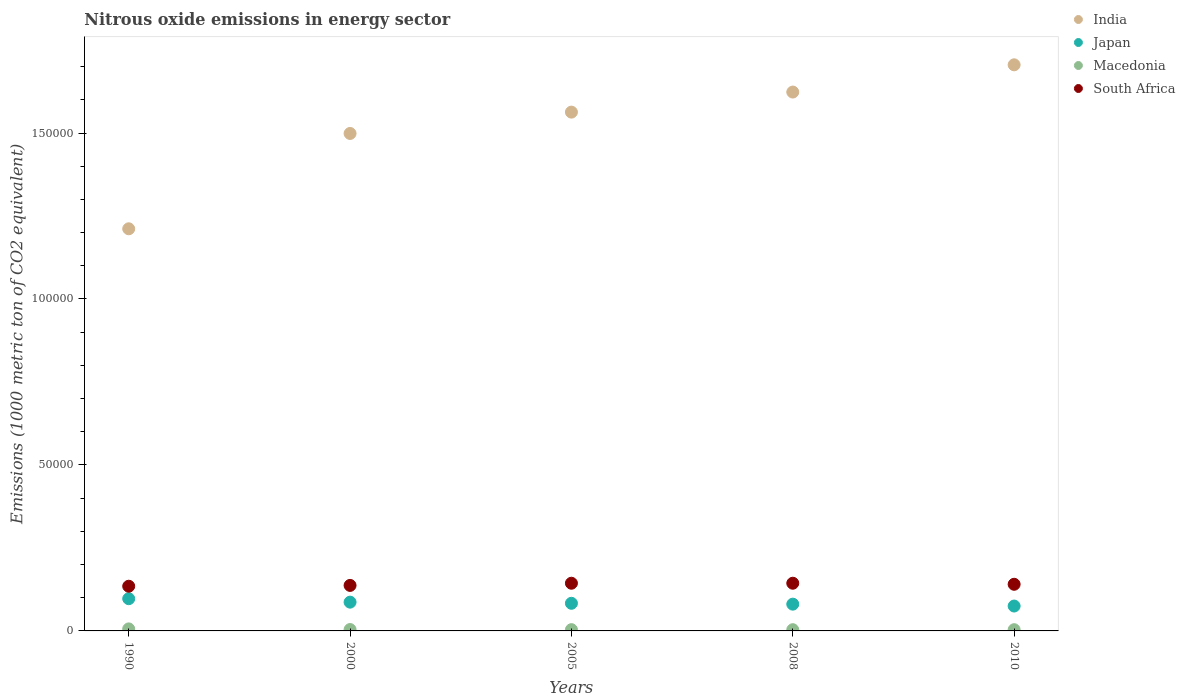What is the amount of nitrous oxide emitted in Macedonia in 2008?
Your response must be concise. 368. Across all years, what is the maximum amount of nitrous oxide emitted in India?
Offer a very short reply. 1.71e+05. Across all years, what is the minimum amount of nitrous oxide emitted in Macedonia?
Provide a succinct answer. 368. In which year was the amount of nitrous oxide emitted in Macedonia maximum?
Your response must be concise. 1990. What is the total amount of nitrous oxide emitted in Macedonia in the graph?
Ensure brevity in your answer.  2151.1. What is the difference between the amount of nitrous oxide emitted in India in 1990 and that in 2000?
Your response must be concise. -2.87e+04. What is the difference between the amount of nitrous oxide emitted in South Africa in 1990 and the amount of nitrous oxide emitted in India in 2010?
Make the answer very short. -1.57e+05. What is the average amount of nitrous oxide emitted in South Africa per year?
Ensure brevity in your answer.  1.40e+04. In the year 2000, what is the difference between the amount of nitrous oxide emitted in India and amount of nitrous oxide emitted in Macedonia?
Your answer should be very brief. 1.49e+05. In how many years, is the amount of nitrous oxide emitted in Macedonia greater than 40000 1000 metric ton?
Give a very brief answer. 0. What is the ratio of the amount of nitrous oxide emitted in India in 2000 to that in 2008?
Provide a succinct answer. 0.92. What is the difference between the highest and the second highest amount of nitrous oxide emitted in Macedonia?
Provide a succinct answer. 192.1. What is the difference between the highest and the lowest amount of nitrous oxide emitted in South Africa?
Provide a succinct answer. 905.7. Is it the case that in every year, the sum of the amount of nitrous oxide emitted in Macedonia and amount of nitrous oxide emitted in India  is greater than the sum of amount of nitrous oxide emitted in South Africa and amount of nitrous oxide emitted in Japan?
Provide a short and direct response. Yes. Does the amount of nitrous oxide emitted in Japan monotonically increase over the years?
Keep it short and to the point. No. Is the amount of nitrous oxide emitted in Japan strictly less than the amount of nitrous oxide emitted in Macedonia over the years?
Offer a terse response. No. How many years are there in the graph?
Give a very brief answer. 5. What is the difference between two consecutive major ticks on the Y-axis?
Your answer should be very brief. 5.00e+04. Does the graph contain grids?
Give a very brief answer. No. Where does the legend appear in the graph?
Give a very brief answer. Top right. How many legend labels are there?
Provide a short and direct response. 4. How are the legend labels stacked?
Offer a very short reply. Vertical. What is the title of the graph?
Ensure brevity in your answer.  Nitrous oxide emissions in energy sector. Does "High income" appear as one of the legend labels in the graph?
Ensure brevity in your answer.  No. What is the label or title of the X-axis?
Provide a short and direct response. Years. What is the label or title of the Y-axis?
Your answer should be compact. Emissions (1000 metric ton of CO2 equivalent). What is the Emissions (1000 metric ton of CO2 equivalent) of India in 1990?
Your response must be concise. 1.21e+05. What is the Emissions (1000 metric ton of CO2 equivalent) in Japan in 1990?
Provide a succinct answer. 9708.8. What is the Emissions (1000 metric ton of CO2 equivalent) in Macedonia in 1990?
Offer a terse response. 610.4. What is the Emissions (1000 metric ton of CO2 equivalent) in South Africa in 1990?
Provide a succinct answer. 1.35e+04. What is the Emissions (1000 metric ton of CO2 equivalent) in India in 2000?
Your answer should be compact. 1.50e+05. What is the Emissions (1000 metric ton of CO2 equivalent) in Japan in 2000?
Your answer should be compact. 8667.2. What is the Emissions (1000 metric ton of CO2 equivalent) in Macedonia in 2000?
Give a very brief answer. 418.3. What is the Emissions (1000 metric ton of CO2 equivalent) of South Africa in 2000?
Your answer should be compact. 1.37e+04. What is the Emissions (1000 metric ton of CO2 equivalent) of India in 2005?
Your answer should be very brief. 1.56e+05. What is the Emissions (1000 metric ton of CO2 equivalent) of Japan in 2005?
Ensure brevity in your answer.  8324.7. What is the Emissions (1000 metric ton of CO2 equivalent) in Macedonia in 2005?
Ensure brevity in your answer.  382.8. What is the Emissions (1000 metric ton of CO2 equivalent) in South Africa in 2005?
Your answer should be compact. 1.44e+04. What is the Emissions (1000 metric ton of CO2 equivalent) of India in 2008?
Provide a succinct answer. 1.62e+05. What is the Emissions (1000 metric ton of CO2 equivalent) of Japan in 2008?
Offer a very short reply. 8063.7. What is the Emissions (1000 metric ton of CO2 equivalent) in Macedonia in 2008?
Offer a terse response. 368. What is the Emissions (1000 metric ton of CO2 equivalent) of South Africa in 2008?
Your response must be concise. 1.44e+04. What is the Emissions (1000 metric ton of CO2 equivalent) of India in 2010?
Give a very brief answer. 1.71e+05. What is the Emissions (1000 metric ton of CO2 equivalent) in Japan in 2010?
Offer a very short reply. 7497.9. What is the Emissions (1000 metric ton of CO2 equivalent) in Macedonia in 2010?
Ensure brevity in your answer.  371.6. What is the Emissions (1000 metric ton of CO2 equivalent) of South Africa in 2010?
Provide a succinct answer. 1.41e+04. Across all years, what is the maximum Emissions (1000 metric ton of CO2 equivalent) in India?
Ensure brevity in your answer.  1.71e+05. Across all years, what is the maximum Emissions (1000 metric ton of CO2 equivalent) of Japan?
Your answer should be very brief. 9708.8. Across all years, what is the maximum Emissions (1000 metric ton of CO2 equivalent) of Macedonia?
Ensure brevity in your answer.  610.4. Across all years, what is the maximum Emissions (1000 metric ton of CO2 equivalent) of South Africa?
Give a very brief answer. 1.44e+04. Across all years, what is the minimum Emissions (1000 metric ton of CO2 equivalent) of India?
Your response must be concise. 1.21e+05. Across all years, what is the minimum Emissions (1000 metric ton of CO2 equivalent) in Japan?
Make the answer very short. 7497.9. Across all years, what is the minimum Emissions (1000 metric ton of CO2 equivalent) of Macedonia?
Keep it short and to the point. 368. Across all years, what is the minimum Emissions (1000 metric ton of CO2 equivalent) of South Africa?
Ensure brevity in your answer.  1.35e+04. What is the total Emissions (1000 metric ton of CO2 equivalent) of India in the graph?
Your answer should be very brief. 7.60e+05. What is the total Emissions (1000 metric ton of CO2 equivalent) of Japan in the graph?
Offer a terse response. 4.23e+04. What is the total Emissions (1000 metric ton of CO2 equivalent) of Macedonia in the graph?
Give a very brief answer. 2151.1. What is the total Emissions (1000 metric ton of CO2 equivalent) of South Africa in the graph?
Make the answer very short. 7.00e+04. What is the difference between the Emissions (1000 metric ton of CO2 equivalent) in India in 1990 and that in 2000?
Your answer should be very brief. -2.87e+04. What is the difference between the Emissions (1000 metric ton of CO2 equivalent) of Japan in 1990 and that in 2000?
Offer a terse response. 1041.6. What is the difference between the Emissions (1000 metric ton of CO2 equivalent) in Macedonia in 1990 and that in 2000?
Your response must be concise. 192.1. What is the difference between the Emissions (1000 metric ton of CO2 equivalent) in South Africa in 1990 and that in 2000?
Keep it short and to the point. -246.5. What is the difference between the Emissions (1000 metric ton of CO2 equivalent) of India in 1990 and that in 2005?
Offer a very short reply. -3.51e+04. What is the difference between the Emissions (1000 metric ton of CO2 equivalent) in Japan in 1990 and that in 2005?
Give a very brief answer. 1384.1. What is the difference between the Emissions (1000 metric ton of CO2 equivalent) of Macedonia in 1990 and that in 2005?
Ensure brevity in your answer.  227.6. What is the difference between the Emissions (1000 metric ton of CO2 equivalent) in South Africa in 1990 and that in 2005?
Make the answer very short. -903.7. What is the difference between the Emissions (1000 metric ton of CO2 equivalent) of India in 1990 and that in 2008?
Give a very brief answer. -4.12e+04. What is the difference between the Emissions (1000 metric ton of CO2 equivalent) in Japan in 1990 and that in 2008?
Keep it short and to the point. 1645.1. What is the difference between the Emissions (1000 metric ton of CO2 equivalent) in Macedonia in 1990 and that in 2008?
Your response must be concise. 242.4. What is the difference between the Emissions (1000 metric ton of CO2 equivalent) of South Africa in 1990 and that in 2008?
Your response must be concise. -905.7. What is the difference between the Emissions (1000 metric ton of CO2 equivalent) in India in 1990 and that in 2010?
Make the answer very short. -4.94e+04. What is the difference between the Emissions (1000 metric ton of CO2 equivalent) in Japan in 1990 and that in 2010?
Give a very brief answer. 2210.9. What is the difference between the Emissions (1000 metric ton of CO2 equivalent) in Macedonia in 1990 and that in 2010?
Your answer should be very brief. 238.8. What is the difference between the Emissions (1000 metric ton of CO2 equivalent) of South Africa in 1990 and that in 2010?
Ensure brevity in your answer.  -588.2. What is the difference between the Emissions (1000 metric ton of CO2 equivalent) in India in 2000 and that in 2005?
Offer a very short reply. -6428.4. What is the difference between the Emissions (1000 metric ton of CO2 equivalent) in Japan in 2000 and that in 2005?
Offer a terse response. 342.5. What is the difference between the Emissions (1000 metric ton of CO2 equivalent) in Macedonia in 2000 and that in 2005?
Your answer should be compact. 35.5. What is the difference between the Emissions (1000 metric ton of CO2 equivalent) of South Africa in 2000 and that in 2005?
Make the answer very short. -657.2. What is the difference between the Emissions (1000 metric ton of CO2 equivalent) of India in 2000 and that in 2008?
Your answer should be very brief. -1.25e+04. What is the difference between the Emissions (1000 metric ton of CO2 equivalent) in Japan in 2000 and that in 2008?
Keep it short and to the point. 603.5. What is the difference between the Emissions (1000 metric ton of CO2 equivalent) in Macedonia in 2000 and that in 2008?
Offer a terse response. 50.3. What is the difference between the Emissions (1000 metric ton of CO2 equivalent) in South Africa in 2000 and that in 2008?
Your answer should be very brief. -659.2. What is the difference between the Emissions (1000 metric ton of CO2 equivalent) of India in 2000 and that in 2010?
Your response must be concise. -2.07e+04. What is the difference between the Emissions (1000 metric ton of CO2 equivalent) of Japan in 2000 and that in 2010?
Keep it short and to the point. 1169.3. What is the difference between the Emissions (1000 metric ton of CO2 equivalent) of Macedonia in 2000 and that in 2010?
Ensure brevity in your answer.  46.7. What is the difference between the Emissions (1000 metric ton of CO2 equivalent) of South Africa in 2000 and that in 2010?
Your answer should be very brief. -341.7. What is the difference between the Emissions (1000 metric ton of CO2 equivalent) of India in 2005 and that in 2008?
Keep it short and to the point. -6044.2. What is the difference between the Emissions (1000 metric ton of CO2 equivalent) in Japan in 2005 and that in 2008?
Keep it short and to the point. 261. What is the difference between the Emissions (1000 metric ton of CO2 equivalent) of South Africa in 2005 and that in 2008?
Provide a succinct answer. -2. What is the difference between the Emissions (1000 metric ton of CO2 equivalent) in India in 2005 and that in 2010?
Your answer should be very brief. -1.43e+04. What is the difference between the Emissions (1000 metric ton of CO2 equivalent) of Japan in 2005 and that in 2010?
Offer a very short reply. 826.8. What is the difference between the Emissions (1000 metric ton of CO2 equivalent) in Macedonia in 2005 and that in 2010?
Ensure brevity in your answer.  11.2. What is the difference between the Emissions (1000 metric ton of CO2 equivalent) of South Africa in 2005 and that in 2010?
Offer a very short reply. 315.5. What is the difference between the Emissions (1000 metric ton of CO2 equivalent) of India in 2008 and that in 2010?
Give a very brief answer. -8207.6. What is the difference between the Emissions (1000 metric ton of CO2 equivalent) of Japan in 2008 and that in 2010?
Your response must be concise. 565.8. What is the difference between the Emissions (1000 metric ton of CO2 equivalent) in South Africa in 2008 and that in 2010?
Offer a very short reply. 317.5. What is the difference between the Emissions (1000 metric ton of CO2 equivalent) of India in 1990 and the Emissions (1000 metric ton of CO2 equivalent) of Japan in 2000?
Provide a short and direct response. 1.12e+05. What is the difference between the Emissions (1000 metric ton of CO2 equivalent) in India in 1990 and the Emissions (1000 metric ton of CO2 equivalent) in Macedonia in 2000?
Your response must be concise. 1.21e+05. What is the difference between the Emissions (1000 metric ton of CO2 equivalent) of India in 1990 and the Emissions (1000 metric ton of CO2 equivalent) of South Africa in 2000?
Your response must be concise. 1.07e+05. What is the difference between the Emissions (1000 metric ton of CO2 equivalent) in Japan in 1990 and the Emissions (1000 metric ton of CO2 equivalent) in Macedonia in 2000?
Provide a succinct answer. 9290.5. What is the difference between the Emissions (1000 metric ton of CO2 equivalent) in Japan in 1990 and the Emissions (1000 metric ton of CO2 equivalent) in South Africa in 2000?
Your answer should be compact. -4001.1. What is the difference between the Emissions (1000 metric ton of CO2 equivalent) of Macedonia in 1990 and the Emissions (1000 metric ton of CO2 equivalent) of South Africa in 2000?
Offer a terse response. -1.31e+04. What is the difference between the Emissions (1000 metric ton of CO2 equivalent) of India in 1990 and the Emissions (1000 metric ton of CO2 equivalent) of Japan in 2005?
Your answer should be very brief. 1.13e+05. What is the difference between the Emissions (1000 metric ton of CO2 equivalent) of India in 1990 and the Emissions (1000 metric ton of CO2 equivalent) of Macedonia in 2005?
Keep it short and to the point. 1.21e+05. What is the difference between the Emissions (1000 metric ton of CO2 equivalent) of India in 1990 and the Emissions (1000 metric ton of CO2 equivalent) of South Africa in 2005?
Make the answer very short. 1.07e+05. What is the difference between the Emissions (1000 metric ton of CO2 equivalent) in Japan in 1990 and the Emissions (1000 metric ton of CO2 equivalent) in Macedonia in 2005?
Ensure brevity in your answer.  9326. What is the difference between the Emissions (1000 metric ton of CO2 equivalent) in Japan in 1990 and the Emissions (1000 metric ton of CO2 equivalent) in South Africa in 2005?
Make the answer very short. -4658.3. What is the difference between the Emissions (1000 metric ton of CO2 equivalent) in Macedonia in 1990 and the Emissions (1000 metric ton of CO2 equivalent) in South Africa in 2005?
Offer a terse response. -1.38e+04. What is the difference between the Emissions (1000 metric ton of CO2 equivalent) in India in 1990 and the Emissions (1000 metric ton of CO2 equivalent) in Japan in 2008?
Provide a succinct answer. 1.13e+05. What is the difference between the Emissions (1000 metric ton of CO2 equivalent) of India in 1990 and the Emissions (1000 metric ton of CO2 equivalent) of Macedonia in 2008?
Your answer should be compact. 1.21e+05. What is the difference between the Emissions (1000 metric ton of CO2 equivalent) of India in 1990 and the Emissions (1000 metric ton of CO2 equivalent) of South Africa in 2008?
Offer a very short reply. 1.07e+05. What is the difference between the Emissions (1000 metric ton of CO2 equivalent) in Japan in 1990 and the Emissions (1000 metric ton of CO2 equivalent) in Macedonia in 2008?
Make the answer very short. 9340.8. What is the difference between the Emissions (1000 metric ton of CO2 equivalent) of Japan in 1990 and the Emissions (1000 metric ton of CO2 equivalent) of South Africa in 2008?
Provide a succinct answer. -4660.3. What is the difference between the Emissions (1000 metric ton of CO2 equivalent) of Macedonia in 1990 and the Emissions (1000 metric ton of CO2 equivalent) of South Africa in 2008?
Keep it short and to the point. -1.38e+04. What is the difference between the Emissions (1000 metric ton of CO2 equivalent) in India in 1990 and the Emissions (1000 metric ton of CO2 equivalent) in Japan in 2010?
Provide a short and direct response. 1.14e+05. What is the difference between the Emissions (1000 metric ton of CO2 equivalent) in India in 1990 and the Emissions (1000 metric ton of CO2 equivalent) in Macedonia in 2010?
Provide a succinct answer. 1.21e+05. What is the difference between the Emissions (1000 metric ton of CO2 equivalent) of India in 1990 and the Emissions (1000 metric ton of CO2 equivalent) of South Africa in 2010?
Your response must be concise. 1.07e+05. What is the difference between the Emissions (1000 metric ton of CO2 equivalent) in Japan in 1990 and the Emissions (1000 metric ton of CO2 equivalent) in Macedonia in 2010?
Give a very brief answer. 9337.2. What is the difference between the Emissions (1000 metric ton of CO2 equivalent) in Japan in 1990 and the Emissions (1000 metric ton of CO2 equivalent) in South Africa in 2010?
Your response must be concise. -4342.8. What is the difference between the Emissions (1000 metric ton of CO2 equivalent) in Macedonia in 1990 and the Emissions (1000 metric ton of CO2 equivalent) in South Africa in 2010?
Your answer should be compact. -1.34e+04. What is the difference between the Emissions (1000 metric ton of CO2 equivalent) of India in 2000 and the Emissions (1000 metric ton of CO2 equivalent) of Japan in 2005?
Ensure brevity in your answer.  1.42e+05. What is the difference between the Emissions (1000 metric ton of CO2 equivalent) of India in 2000 and the Emissions (1000 metric ton of CO2 equivalent) of Macedonia in 2005?
Provide a succinct answer. 1.49e+05. What is the difference between the Emissions (1000 metric ton of CO2 equivalent) of India in 2000 and the Emissions (1000 metric ton of CO2 equivalent) of South Africa in 2005?
Give a very brief answer. 1.36e+05. What is the difference between the Emissions (1000 metric ton of CO2 equivalent) in Japan in 2000 and the Emissions (1000 metric ton of CO2 equivalent) in Macedonia in 2005?
Offer a terse response. 8284.4. What is the difference between the Emissions (1000 metric ton of CO2 equivalent) of Japan in 2000 and the Emissions (1000 metric ton of CO2 equivalent) of South Africa in 2005?
Make the answer very short. -5699.9. What is the difference between the Emissions (1000 metric ton of CO2 equivalent) of Macedonia in 2000 and the Emissions (1000 metric ton of CO2 equivalent) of South Africa in 2005?
Your response must be concise. -1.39e+04. What is the difference between the Emissions (1000 metric ton of CO2 equivalent) in India in 2000 and the Emissions (1000 metric ton of CO2 equivalent) in Japan in 2008?
Your response must be concise. 1.42e+05. What is the difference between the Emissions (1000 metric ton of CO2 equivalent) in India in 2000 and the Emissions (1000 metric ton of CO2 equivalent) in Macedonia in 2008?
Ensure brevity in your answer.  1.50e+05. What is the difference between the Emissions (1000 metric ton of CO2 equivalent) of India in 2000 and the Emissions (1000 metric ton of CO2 equivalent) of South Africa in 2008?
Give a very brief answer. 1.36e+05. What is the difference between the Emissions (1000 metric ton of CO2 equivalent) in Japan in 2000 and the Emissions (1000 metric ton of CO2 equivalent) in Macedonia in 2008?
Give a very brief answer. 8299.2. What is the difference between the Emissions (1000 metric ton of CO2 equivalent) in Japan in 2000 and the Emissions (1000 metric ton of CO2 equivalent) in South Africa in 2008?
Ensure brevity in your answer.  -5701.9. What is the difference between the Emissions (1000 metric ton of CO2 equivalent) in Macedonia in 2000 and the Emissions (1000 metric ton of CO2 equivalent) in South Africa in 2008?
Offer a very short reply. -1.40e+04. What is the difference between the Emissions (1000 metric ton of CO2 equivalent) in India in 2000 and the Emissions (1000 metric ton of CO2 equivalent) in Japan in 2010?
Your response must be concise. 1.42e+05. What is the difference between the Emissions (1000 metric ton of CO2 equivalent) of India in 2000 and the Emissions (1000 metric ton of CO2 equivalent) of Macedonia in 2010?
Your response must be concise. 1.49e+05. What is the difference between the Emissions (1000 metric ton of CO2 equivalent) in India in 2000 and the Emissions (1000 metric ton of CO2 equivalent) in South Africa in 2010?
Offer a very short reply. 1.36e+05. What is the difference between the Emissions (1000 metric ton of CO2 equivalent) of Japan in 2000 and the Emissions (1000 metric ton of CO2 equivalent) of Macedonia in 2010?
Provide a succinct answer. 8295.6. What is the difference between the Emissions (1000 metric ton of CO2 equivalent) in Japan in 2000 and the Emissions (1000 metric ton of CO2 equivalent) in South Africa in 2010?
Provide a succinct answer. -5384.4. What is the difference between the Emissions (1000 metric ton of CO2 equivalent) of Macedonia in 2000 and the Emissions (1000 metric ton of CO2 equivalent) of South Africa in 2010?
Offer a terse response. -1.36e+04. What is the difference between the Emissions (1000 metric ton of CO2 equivalent) of India in 2005 and the Emissions (1000 metric ton of CO2 equivalent) of Japan in 2008?
Give a very brief answer. 1.48e+05. What is the difference between the Emissions (1000 metric ton of CO2 equivalent) in India in 2005 and the Emissions (1000 metric ton of CO2 equivalent) in Macedonia in 2008?
Your response must be concise. 1.56e+05. What is the difference between the Emissions (1000 metric ton of CO2 equivalent) in India in 2005 and the Emissions (1000 metric ton of CO2 equivalent) in South Africa in 2008?
Your answer should be very brief. 1.42e+05. What is the difference between the Emissions (1000 metric ton of CO2 equivalent) of Japan in 2005 and the Emissions (1000 metric ton of CO2 equivalent) of Macedonia in 2008?
Ensure brevity in your answer.  7956.7. What is the difference between the Emissions (1000 metric ton of CO2 equivalent) in Japan in 2005 and the Emissions (1000 metric ton of CO2 equivalent) in South Africa in 2008?
Provide a short and direct response. -6044.4. What is the difference between the Emissions (1000 metric ton of CO2 equivalent) in Macedonia in 2005 and the Emissions (1000 metric ton of CO2 equivalent) in South Africa in 2008?
Provide a succinct answer. -1.40e+04. What is the difference between the Emissions (1000 metric ton of CO2 equivalent) in India in 2005 and the Emissions (1000 metric ton of CO2 equivalent) in Japan in 2010?
Give a very brief answer. 1.49e+05. What is the difference between the Emissions (1000 metric ton of CO2 equivalent) in India in 2005 and the Emissions (1000 metric ton of CO2 equivalent) in Macedonia in 2010?
Offer a very short reply. 1.56e+05. What is the difference between the Emissions (1000 metric ton of CO2 equivalent) in India in 2005 and the Emissions (1000 metric ton of CO2 equivalent) in South Africa in 2010?
Your answer should be compact. 1.42e+05. What is the difference between the Emissions (1000 metric ton of CO2 equivalent) in Japan in 2005 and the Emissions (1000 metric ton of CO2 equivalent) in Macedonia in 2010?
Ensure brevity in your answer.  7953.1. What is the difference between the Emissions (1000 metric ton of CO2 equivalent) in Japan in 2005 and the Emissions (1000 metric ton of CO2 equivalent) in South Africa in 2010?
Your answer should be very brief. -5726.9. What is the difference between the Emissions (1000 metric ton of CO2 equivalent) in Macedonia in 2005 and the Emissions (1000 metric ton of CO2 equivalent) in South Africa in 2010?
Make the answer very short. -1.37e+04. What is the difference between the Emissions (1000 metric ton of CO2 equivalent) of India in 2008 and the Emissions (1000 metric ton of CO2 equivalent) of Japan in 2010?
Your response must be concise. 1.55e+05. What is the difference between the Emissions (1000 metric ton of CO2 equivalent) in India in 2008 and the Emissions (1000 metric ton of CO2 equivalent) in Macedonia in 2010?
Your response must be concise. 1.62e+05. What is the difference between the Emissions (1000 metric ton of CO2 equivalent) of India in 2008 and the Emissions (1000 metric ton of CO2 equivalent) of South Africa in 2010?
Keep it short and to the point. 1.48e+05. What is the difference between the Emissions (1000 metric ton of CO2 equivalent) of Japan in 2008 and the Emissions (1000 metric ton of CO2 equivalent) of Macedonia in 2010?
Your answer should be very brief. 7692.1. What is the difference between the Emissions (1000 metric ton of CO2 equivalent) of Japan in 2008 and the Emissions (1000 metric ton of CO2 equivalent) of South Africa in 2010?
Ensure brevity in your answer.  -5987.9. What is the difference between the Emissions (1000 metric ton of CO2 equivalent) of Macedonia in 2008 and the Emissions (1000 metric ton of CO2 equivalent) of South Africa in 2010?
Keep it short and to the point. -1.37e+04. What is the average Emissions (1000 metric ton of CO2 equivalent) of India per year?
Provide a short and direct response. 1.52e+05. What is the average Emissions (1000 metric ton of CO2 equivalent) in Japan per year?
Provide a succinct answer. 8452.46. What is the average Emissions (1000 metric ton of CO2 equivalent) of Macedonia per year?
Make the answer very short. 430.22. What is the average Emissions (1000 metric ton of CO2 equivalent) in South Africa per year?
Provide a short and direct response. 1.40e+04. In the year 1990, what is the difference between the Emissions (1000 metric ton of CO2 equivalent) of India and Emissions (1000 metric ton of CO2 equivalent) of Japan?
Provide a short and direct response. 1.11e+05. In the year 1990, what is the difference between the Emissions (1000 metric ton of CO2 equivalent) of India and Emissions (1000 metric ton of CO2 equivalent) of Macedonia?
Offer a terse response. 1.21e+05. In the year 1990, what is the difference between the Emissions (1000 metric ton of CO2 equivalent) of India and Emissions (1000 metric ton of CO2 equivalent) of South Africa?
Offer a very short reply. 1.08e+05. In the year 1990, what is the difference between the Emissions (1000 metric ton of CO2 equivalent) of Japan and Emissions (1000 metric ton of CO2 equivalent) of Macedonia?
Provide a short and direct response. 9098.4. In the year 1990, what is the difference between the Emissions (1000 metric ton of CO2 equivalent) in Japan and Emissions (1000 metric ton of CO2 equivalent) in South Africa?
Ensure brevity in your answer.  -3754.6. In the year 1990, what is the difference between the Emissions (1000 metric ton of CO2 equivalent) in Macedonia and Emissions (1000 metric ton of CO2 equivalent) in South Africa?
Make the answer very short. -1.29e+04. In the year 2000, what is the difference between the Emissions (1000 metric ton of CO2 equivalent) in India and Emissions (1000 metric ton of CO2 equivalent) in Japan?
Keep it short and to the point. 1.41e+05. In the year 2000, what is the difference between the Emissions (1000 metric ton of CO2 equivalent) in India and Emissions (1000 metric ton of CO2 equivalent) in Macedonia?
Make the answer very short. 1.49e+05. In the year 2000, what is the difference between the Emissions (1000 metric ton of CO2 equivalent) of India and Emissions (1000 metric ton of CO2 equivalent) of South Africa?
Make the answer very short. 1.36e+05. In the year 2000, what is the difference between the Emissions (1000 metric ton of CO2 equivalent) in Japan and Emissions (1000 metric ton of CO2 equivalent) in Macedonia?
Your answer should be very brief. 8248.9. In the year 2000, what is the difference between the Emissions (1000 metric ton of CO2 equivalent) in Japan and Emissions (1000 metric ton of CO2 equivalent) in South Africa?
Your response must be concise. -5042.7. In the year 2000, what is the difference between the Emissions (1000 metric ton of CO2 equivalent) in Macedonia and Emissions (1000 metric ton of CO2 equivalent) in South Africa?
Your answer should be compact. -1.33e+04. In the year 2005, what is the difference between the Emissions (1000 metric ton of CO2 equivalent) of India and Emissions (1000 metric ton of CO2 equivalent) of Japan?
Offer a terse response. 1.48e+05. In the year 2005, what is the difference between the Emissions (1000 metric ton of CO2 equivalent) in India and Emissions (1000 metric ton of CO2 equivalent) in Macedonia?
Make the answer very short. 1.56e+05. In the year 2005, what is the difference between the Emissions (1000 metric ton of CO2 equivalent) in India and Emissions (1000 metric ton of CO2 equivalent) in South Africa?
Your answer should be very brief. 1.42e+05. In the year 2005, what is the difference between the Emissions (1000 metric ton of CO2 equivalent) of Japan and Emissions (1000 metric ton of CO2 equivalent) of Macedonia?
Your answer should be very brief. 7941.9. In the year 2005, what is the difference between the Emissions (1000 metric ton of CO2 equivalent) in Japan and Emissions (1000 metric ton of CO2 equivalent) in South Africa?
Offer a terse response. -6042.4. In the year 2005, what is the difference between the Emissions (1000 metric ton of CO2 equivalent) of Macedonia and Emissions (1000 metric ton of CO2 equivalent) of South Africa?
Provide a short and direct response. -1.40e+04. In the year 2008, what is the difference between the Emissions (1000 metric ton of CO2 equivalent) of India and Emissions (1000 metric ton of CO2 equivalent) of Japan?
Provide a succinct answer. 1.54e+05. In the year 2008, what is the difference between the Emissions (1000 metric ton of CO2 equivalent) in India and Emissions (1000 metric ton of CO2 equivalent) in Macedonia?
Your answer should be very brief. 1.62e+05. In the year 2008, what is the difference between the Emissions (1000 metric ton of CO2 equivalent) in India and Emissions (1000 metric ton of CO2 equivalent) in South Africa?
Provide a short and direct response. 1.48e+05. In the year 2008, what is the difference between the Emissions (1000 metric ton of CO2 equivalent) in Japan and Emissions (1000 metric ton of CO2 equivalent) in Macedonia?
Provide a short and direct response. 7695.7. In the year 2008, what is the difference between the Emissions (1000 metric ton of CO2 equivalent) of Japan and Emissions (1000 metric ton of CO2 equivalent) of South Africa?
Provide a succinct answer. -6305.4. In the year 2008, what is the difference between the Emissions (1000 metric ton of CO2 equivalent) of Macedonia and Emissions (1000 metric ton of CO2 equivalent) of South Africa?
Provide a succinct answer. -1.40e+04. In the year 2010, what is the difference between the Emissions (1000 metric ton of CO2 equivalent) in India and Emissions (1000 metric ton of CO2 equivalent) in Japan?
Ensure brevity in your answer.  1.63e+05. In the year 2010, what is the difference between the Emissions (1000 metric ton of CO2 equivalent) of India and Emissions (1000 metric ton of CO2 equivalent) of Macedonia?
Make the answer very short. 1.70e+05. In the year 2010, what is the difference between the Emissions (1000 metric ton of CO2 equivalent) of India and Emissions (1000 metric ton of CO2 equivalent) of South Africa?
Keep it short and to the point. 1.56e+05. In the year 2010, what is the difference between the Emissions (1000 metric ton of CO2 equivalent) in Japan and Emissions (1000 metric ton of CO2 equivalent) in Macedonia?
Offer a very short reply. 7126.3. In the year 2010, what is the difference between the Emissions (1000 metric ton of CO2 equivalent) in Japan and Emissions (1000 metric ton of CO2 equivalent) in South Africa?
Keep it short and to the point. -6553.7. In the year 2010, what is the difference between the Emissions (1000 metric ton of CO2 equivalent) of Macedonia and Emissions (1000 metric ton of CO2 equivalent) of South Africa?
Offer a terse response. -1.37e+04. What is the ratio of the Emissions (1000 metric ton of CO2 equivalent) of India in 1990 to that in 2000?
Provide a succinct answer. 0.81. What is the ratio of the Emissions (1000 metric ton of CO2 equivalent) of Japan in 1990 to that in 2000?
Provide a succinct answer. 1.12. What is the ratio of the Emissions (1000 metric ton of CO2 equivalent) of Macedonia in 1990 to that in 2000?
Keep it short and to the point. 1.46. What is the ratio of the Emissions (1000 metric ton of CO2 equivalent) in South Africa in 1990 to that in 2000?
Provide a succinct answer. 0.98. What is the ratio of the Emissions (1000 metric ton of CO2 equivalent) in India in 1990 to that in 2005?
Offer a terse response. 0.78. What is the ratio of the Emissions (1000 metric ton of CO2 equivalent) in Japan in 1990 to that in 2005?
Your answer should be very brief. 1.17. What is the ratio of the Emissions (1000 metric ton of CO2 equivalent) in Macedonia in 1990 to that in 2005?
Keep it short and to the point. 1.59. What is the ratio of the Emissions (1000 metric ton of CO2 equivalent) in South Africa in 1990 to that in 2005?
Offer a very short reply. 0.94. What is the ratio of the Emissions (1000 metric ton of CO2 equivalent) in India in 1990 to that in 2008?
Your response must be concise. 0.75. What is the ratio of the Emissions (1000 metric ton of CO2 equivalent) in Japan in 1990 to that in 2008?
Make the answer very short. 1.2. What is the ratio of the Emissions (1000 metric ton of CO2 equivalent) of Macedonia in 1990 to that in 2008?
Make the answer very short. 1.66. What is the ratio of the Emissions (1000 metric ton of CO2 equivalent) in South Africa in 1990 to that in 2008?
Your answer should be very brief. 0.94. What is the ratio of the Emissions (1000 metric ton of CO2 equivalent) in India in 1990 to that in 2010?
Your response must be concise. 0.71. What is the ratio of the Emissions (1000 metric ton of CO2 equivalent) in Japan in 1990 to that in 2010?
Make the answer very short. 1.29. What is the ratio of the Emissions (1000 metric ton of CO2 equivalent) of Macedonia in 1990 to that in 2010?
Your response must be concise. 1.64. What is the ratio of the Emissions (1000 metric ton of CO2 equivalent) of South Africa in 1990 to that in 2010?
Your answer should be very brief. 0.96. What is the ratio of the Emissions (1000 metric ton of CO2 equivalent) of India in 2000 to that in 2005?
Offer a terse response. 0.96. What is the ratio of the Emissions (1000 metric ton of CO2 equivalent) of Japan in 2000 to that in 2005?
Ensure brevity in your answer.  1.04. What is the ratio of the Emissions (1000 metric ton of CO2 equivalent) of Macedonia in 2000 to that in 2005?
Keep it short and to the point. 1.09. What is the ratio of the Emissions (1000 metric ton of CO2 equivalent) of South Africa in 2000 to that in 2005?
Provide a succinct answer. 0.95. What is the ratio of the Emissions (1000 metric ton of CO2 equivalent) in India in 2000 to that in 2008?
Make the answer very short. 0.92. What is the ratio of the Emissions (1000 metric ton of CO2 equivalent) of Japan in 2000 to that in 2008?
Your answer should be compact. 1.07. What is the ratio of the Emissions (1000 metric ton of CO2 equivalent) in Macedonia in 2000 to that in 2008?
Offer a terse response. 1.14. What is the ratio of the Emissions (1000 metric ton of CO2 equivalent) of South Africa in 2000 to that in 2008?
Offer a terse response. 0.95. What is the ratio of the Emissions (1000 metric ton of CO2 equivalent) of India in 2000 to that in 2010?
Give a very brief answer. 0.88. What is the ratio of the Emissions (1000 metric ton of CO2 equivalent) of Japan in 2000 to that in 2010?
Ensure brevity in your answer.  1.16. What is the ratio of the Emissions (1000 metric ton of CO2 equivalent) in Macedonia in 2000 to that in 2010?
Give a very brief answer. 1.13. What is the ratio of the Emissions (1000 metric ton of CO2 equivalent) in South Africa in 2000 to that in 2010?
Your response must be concise. 0.98. What is the ratio of the Emissions (1000 metric ton of CO2 equivalent) in India in 2005 to that in 2008?
Offer a terse response. 0.96. What is the ratio of the Emissions (1000 metric ton of CO2 equivalent) in Japan in 2005 to that in 2008?
Provide a short and direct response. 1.03. What is the ratio of the Emissions (1000 metric ton of CO2 equivalent) of Macedonia in 2005 to that in 2008?
Offer a very short reply. 1.04. What is the ratio of the Emissions (1000 metric ton of CO2 equivalent) in South Africa in 2005 to that in 2008?
Give a very brief answer. 1. What is the ratio of the Emissions (1000 metric ton of CO2 equivalent) of India in 2005 to that in 2010?
Give a very brief answer. 0.92. What is the ratio of the Emissions (1000 metric ton of CO2 equivalent) of Japan in 2005 to that in 2010?
Your response must be concise. 1.11. What is the ratio of the Emissions (1000 metric ton of CO2 equivalent) in Macedonia in 2005 to that in 2010?
Provide a short and direct response. 1.03. What is the ratio of the Emissions (1000 metric ton of CO2 equivalent) of South Africa in 2005 to that in 2010?
Provide a short and direct response. 1.02. What is the ratio of the Emissions (1000 metric ton of CO2 equivalent) in India in 2008 to that in 2010?
Ensure brevity in your answer.  0.95. What is the ratio of the Emissions (1000 metric ton of CO2 equivalent) of Japan in 2008 to that in 2010?
Your answer should be compact. 1.08. What is the ratio of the Emissions (1000 metric ton of CO2 equivalent) in Macedonia in 2008 to that in 2010?
Your answer should be very brief. 0.99. What is the ratio of the Emissions (1000 metric ton of CO2 equivalent) in South Africa in 2008 to that in 2010?
Keep it short and to the point. 1.02. What is the difference between the highest and the second highest Emissions (1000 metric ton of CO2 equivalent) in India?
Your answer should be very brief. 8207.6. What is the difference between the highest and the second highest Emissions (1000 metric ton of CO2 equivalent) in Japan?
Make the answer very short. 1041.6. What is the difference between the highest and the second highest Emissions (1000 metric ton of CO2 equivalent) in Macedonia?
Your answer should be very brief. 192.1. What is the difference between the highest and the second highest Emissions (1000 metric ton of CO2 equivalent) of South Africa?
Provide a succinct answer. 2. What is the difference between the highest and the lowest Emissions (1000 metric ton of CO2 equivalent) of India?
Make the answer very short. 4.94e+04. What is the difference between the highest and the lowest Emissions (1000 metric ton of CO2 equivalent) in Japan?
Keep it short and to the point. 2210.9. What is the difference between the highest and the lowest Emissions (1000 metric ton of CO2 equivalent) in Macedonia?
Your answer should be very brief. 242.4. What is the difference between the highest and the lowest Emissions (1000 metric ton of CO2 equivalent) in South Africa?
Offer a very short reply. 905.7. 